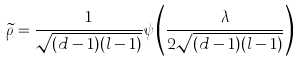<formula> <loc_0><loc_0><loc_500><loc_500>\widetilde { \rho } = \frac { 1 } { \sqrt { ( d - 1 ) ( l - 1 ) } } \psi \left ( \frac { \lambda } { 2 \sqrt { ( d - 1 ) ( l - 1 ) } } \right )</formula> 